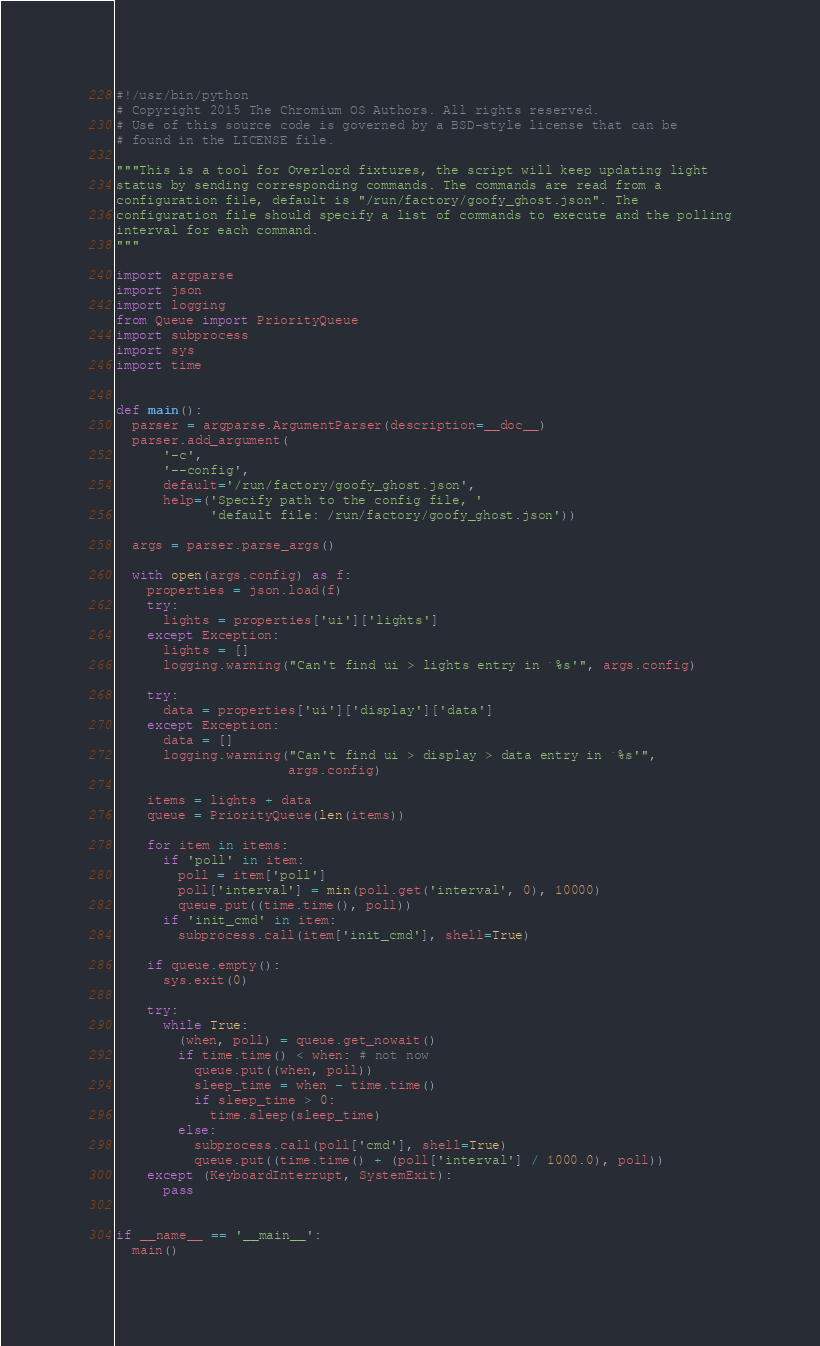<code> <loc_0><loc_0><loc_500><loc_500><_Python_>#!/usr/bin/python
# Copyright 2015 The Chromium OS Authors. All rights reserved.
# Use of this source code is governed by a BSD-style license that can be
# found in the LICENSE file.

"""This is a tool for Overlord fixtures, the script will keep updating light
status by sending corresponding commands. The commands are read from a
configuration file, default is "/run/factory/goofy_ghost.json". The
configuration file should specify a list of commands to execute and the polling
interval for each command.
"""

import argparse
import json
import logging
from Queue import PriorityQueue
import subprocess
import sys
import time


def main():
  parser = argparse.ArgumentParser(description=__doc__)
  parser.add_argument(
      '-c',
      '--config',
      default='/run/factory/goofy_ghost.json',
      help=('Specify path to the config file, '
            'default file: /run/factory/goofy_ghost.json'))

  args = parser.parse_args()

  with open(args.config) as f:
    properties = json.load(f)
    try:
      lights = properties['ui']['lights']
    except Exception:
      lights = []
      logging.warning("Can't find ui > lights entry in `%s'", args.config)

    try:
      data = properties['ui']['display']['data']
    except Exception:
      data = []
      logging.warning("Can't find ui > display > data entry in `%s'",
                      args.config)

    items = lights + data
    queue = PriorityQueue(len(items))

    for item in items:
      if 'poll' in item:
        poll = item['poll']
        poll['interval'] = min(poll.get('interval', 0), 10000)
        queue.put((time.time(), poll))
      if 'init_cmd' in item:
        subprocess.call(item['init_cmd'], shell=True)

    if queue.empty():
      sys.exit(0)

    try:
      while True:
        (when, poll) = queue.get_nowait()
        if time.time() < when: # not now
          queue.put((when, poll))
          sleep_time = when - time.time()
          if sleep_time > 0:
            time.sleep(sleep_time)
        else:
          subprocess.call(poll['cmd'], shell=True)
          queue.put((time.time() + (poll['interval'] / 1000.0), poll))
    except (KeyboardInterrupt, SystemExit):
      pass


if __name__ == '__main__':
  main()
</code> 